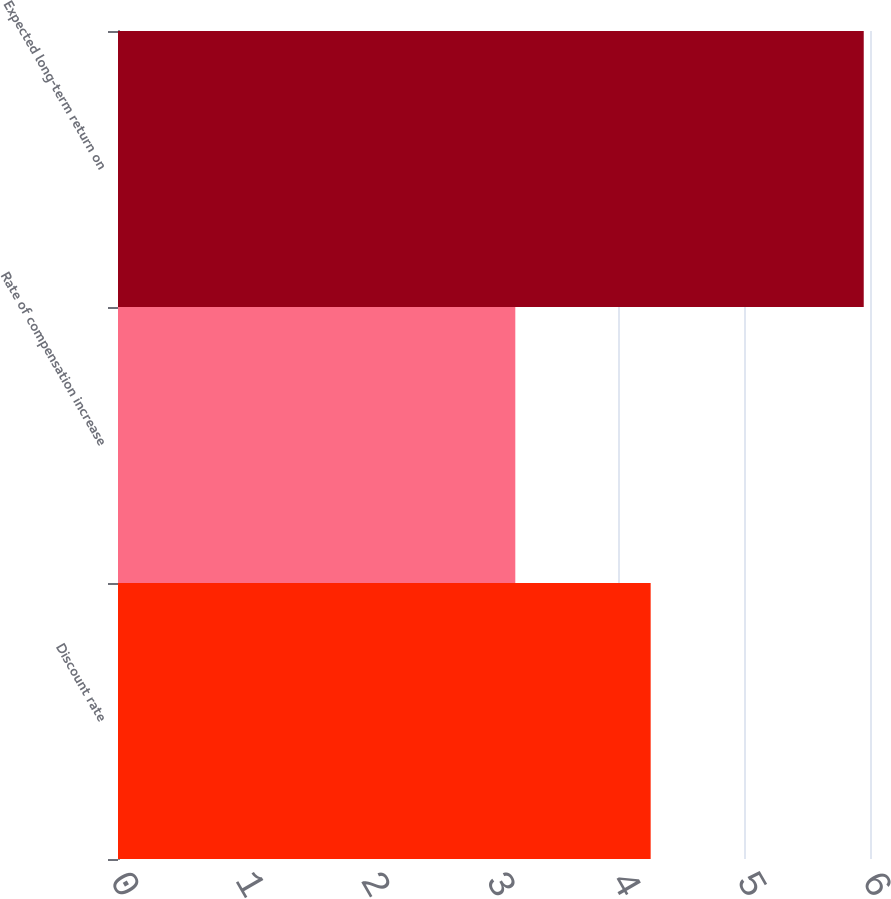<chart> <loc_0><loc_0><loc_500><loc_500><bar_chart><fcel>Discount rate<fcel>Rate of compensation increase<fcel>Expected long-term return on<nl><fcel>4.25<fcel>3.17<fcel>5.95<nl></chart> 